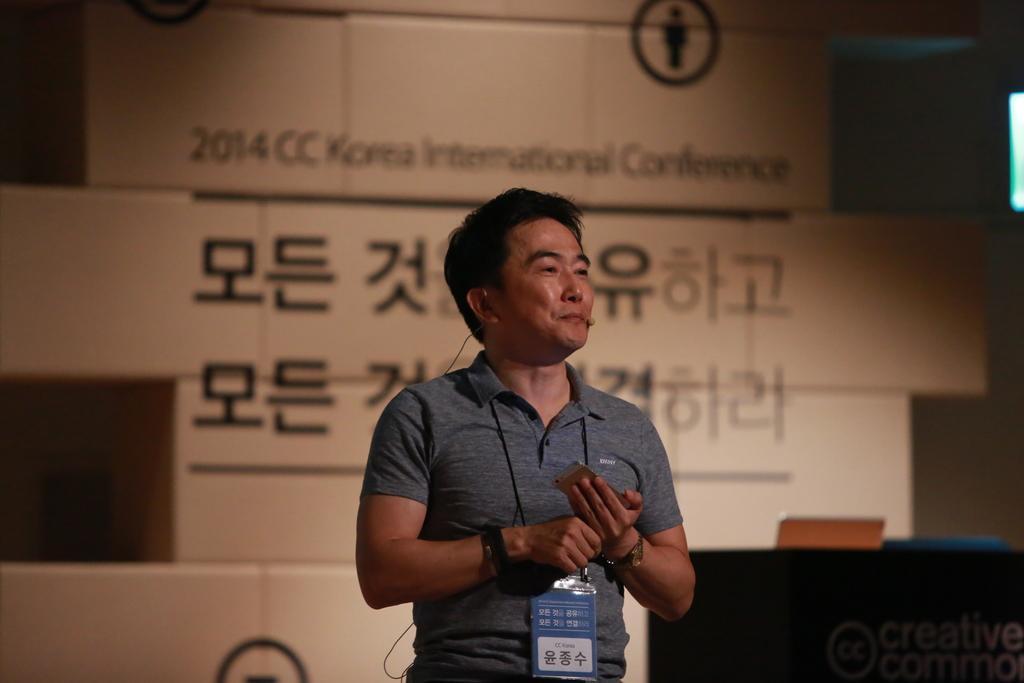Please provide a concise description of this image. In this image there is a person standing and looking to the left side of the image, behind him there are few blogs with some text and images on it. On the right side of the image there is a table, on the table there is a laptop and some text on the table. 